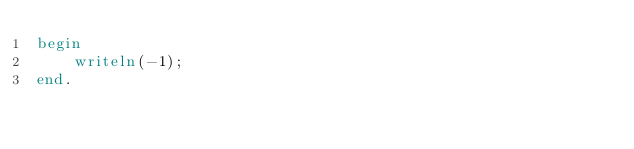<code> <loc_0><loc_0><loc_500><loc_500><_Pascal_>begin
    writeln(-1);
end.</code> 